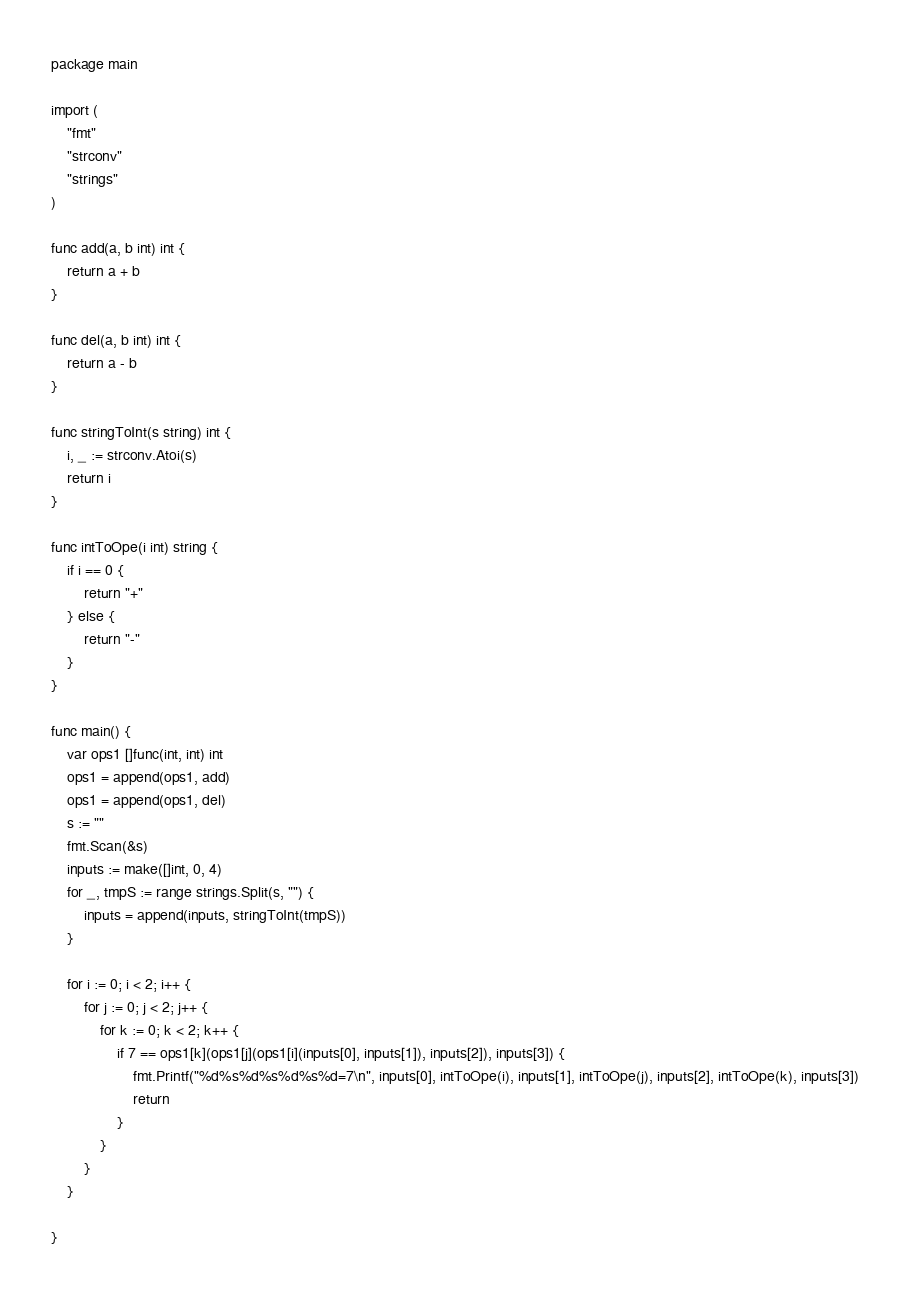Convert code to text. <code><loc_0><loc_0><loc_500><loc_500><_Go_>package main

import (
	"fmt"
	"strconv"
	"strings"
)

func add(a, b int) int {
	return a + b
}

func del(a, b int) int {
	return a - b
}

func stringToInt(s string) int {
	i, _ := strconv.Atoi(s)
	return i
}

func intToOpe(i int) string {
	if i == 0 {
		return "+"
	} else {
		return "-"
	}
}

func main() {
	var ops1 []func(int, int) int
	ops1 = append(ops1, add)
	ops1 = append(ops1, del)
	s := ""
	fmt.Scan(&s)
	inputs := make([]int, 0, 4)
	for _, tmpS := range strings.Split(s, "") {
		inputs = append(inputs, stringToInt(tmpS))
	}

	for i := 0; i < 2; i++ {
		for j := 0; j < 2; j++ {
			for k := 0; k < 2; k++ {
				if 7 == ops1[k](ops1[j](ops1[i](inputs[0], inputs[1]), inputs[2]), inputs[3]) {
					fmt.Printf("%d%s%d%s%d%s%d=7\n", inputs[0], intToOpe(i), inputs[1], intToOpe(j), inputs[2], intToOpe(k), inputs[3])
					return
				}
			}
		}
	}

}</code> 